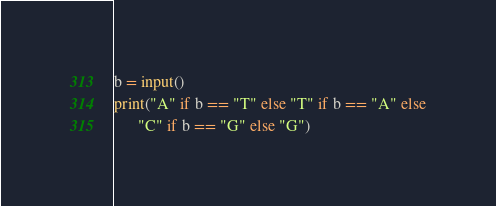<code> <loc_0><loc_0><loc_500><loc_500><_Python_>b = input()
print("A" if b == "T" else "T" if b == "A" else
      "C" if b == "G" else "G")
</code> 